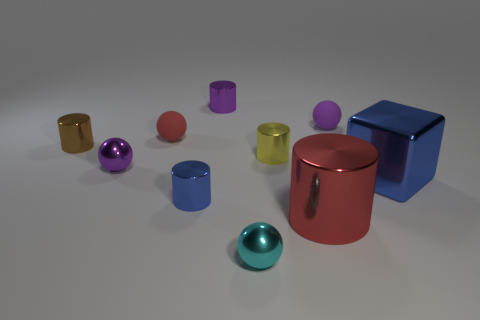Subtract all red balls. How many balls are left? 3 Subtract 5 cylinders. How many cylinders are left? 0 Subtract all red spheres. How many yellow cubes are left? 0 Subtract all cyan things. Subtract all small purple cylinders. How many objects are left? 8 Add 7 blue shiny blocks. How many blue shiny blocks are left? 8 Add 1 big shiny objects. How many big shiny objects exist? 3 Subtract all purple cylinders. How many cylinders are left? 4 Subtract 0 green cylinders. How many objects are left? 10 Subtract all cubes. How many objects are left? 9 Subtract all red blocks. Subtract all brown cylinders. How many blocks are left? 1 